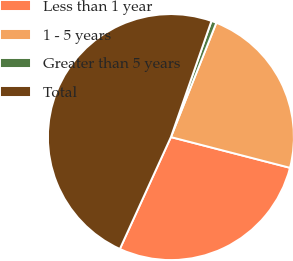<chart> <loc_0><loc_0><loc_500><loc_500><pie_chart><fcel>Less than 1 year<fcel>1 - 5 years<fcel>Greater than 5 years<fcel>Total<nl><fcel>27.79%<fcel>23.0%<fcel>0.67%<fcel>48.53%<nl></chart> 